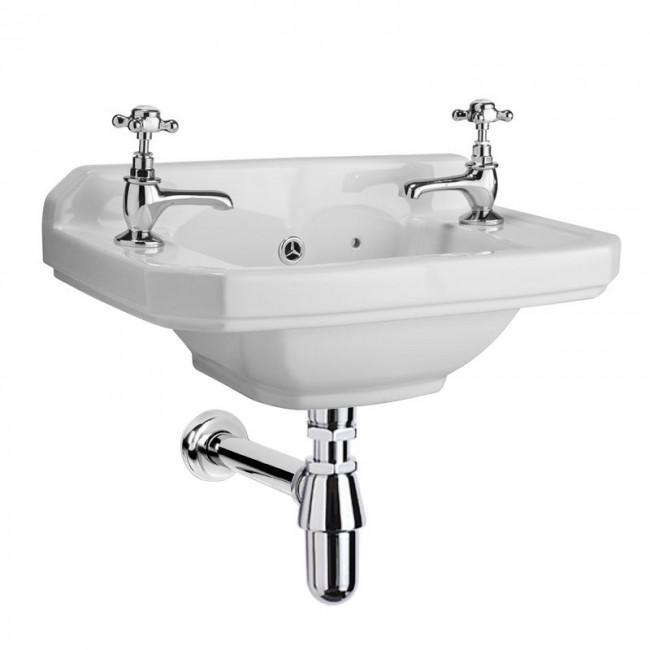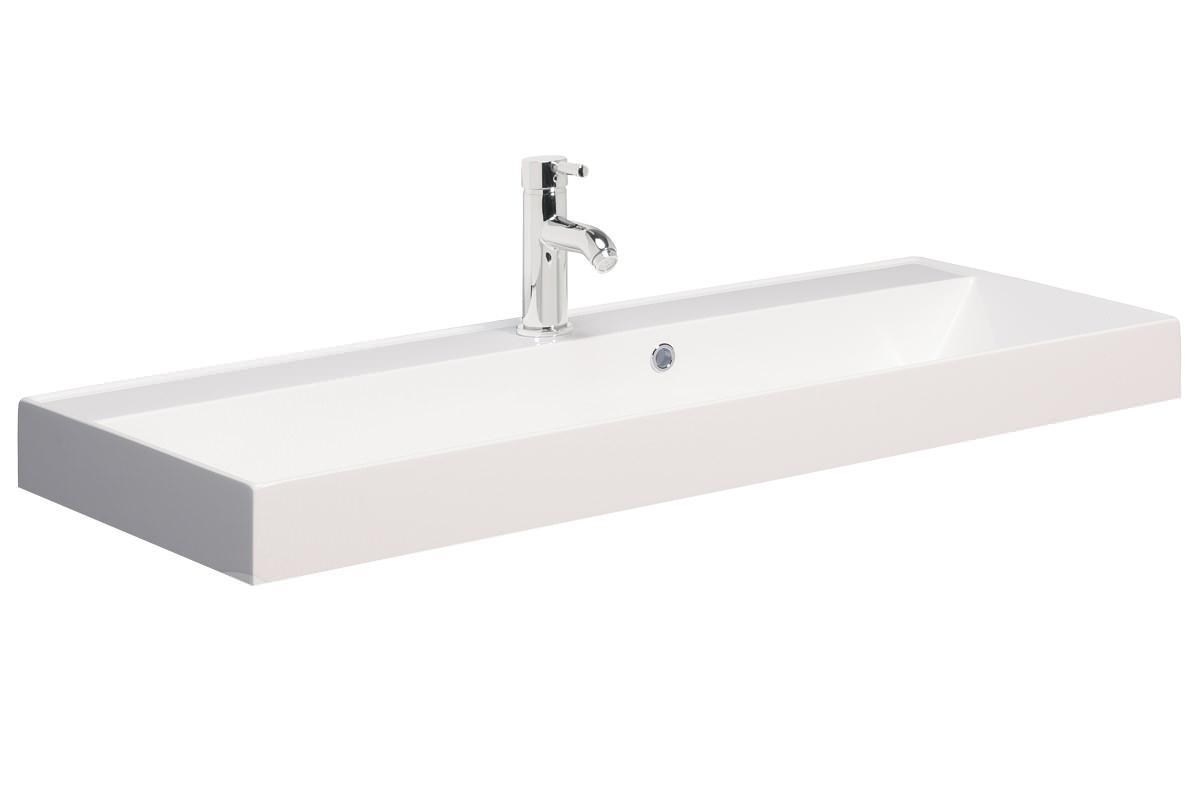The first image is the image on the left, the second image is the image on the right. Analyze the images presented: Is the assertion "None of the faucets are the rotating kind." valid? Answer yes or no. No. 